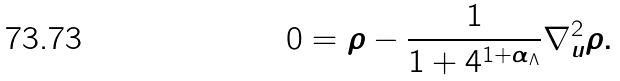<formula> <loc_0><loc_0><loc_500><loc_500>0 = \rho - \frac { 1 } { 1 + 4 ^ { 1 + { \alpha _ { \Lambda } } } } \nabla ^ { 2 } _ { u } \rho .</formula> 